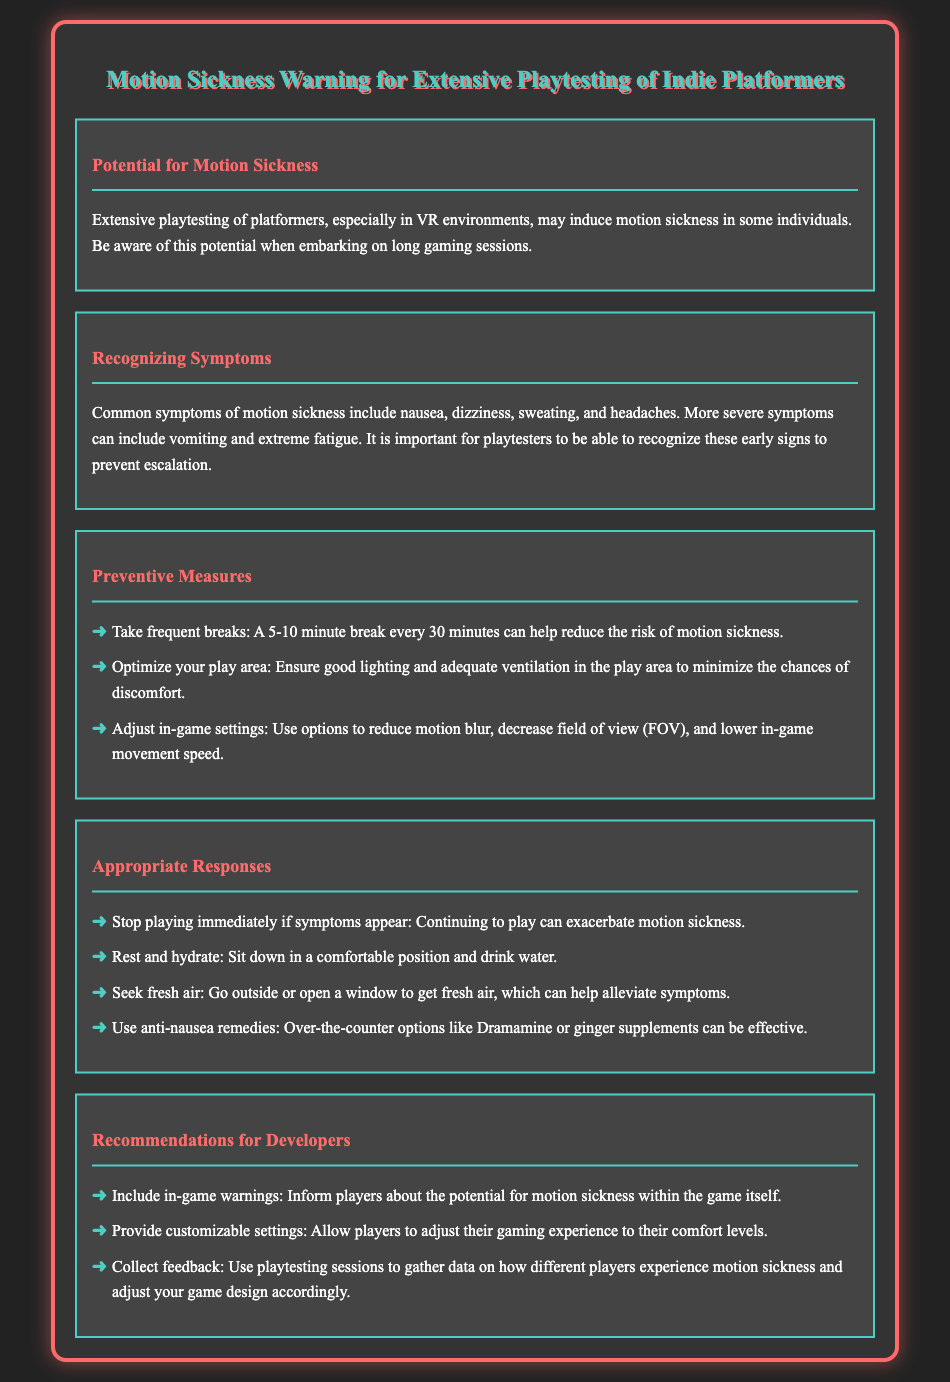what are common symptoms of motion sickness? The document lists nausea, dizziness, sweating, headaches, vomiting, and extreme fatigue as common symptoms.
Answer: nausea, dizziness, sweating, headaches, vomiting, extreme fatigue how long should breaks be during playtesting? The document states that a 5-10 minute break every 30 minutes can help reduce the risk of motion sickness.
Answer: 5-10 minutes what should you do if symptoms appear? The document advises stopping playing immediately if symptoms appear.
Answer: Stop playing immediately what is a preventive measure regarding the play area? The document suggests ensuring good lighting and adequate ventilation in the play area as a preventive measure.
Answer: Good lighting and ventilation which remedy is mentioned for nausea? The document mentions over-the-counter options like Dramamine or ginger supplements as remedies for nausea.
Answer: Dramamine, ginger supplements what potential issue does extensive playtesting in VR environments pose? The document highlights that extensive playtesting may induce motion sickness in some individuals.
Answer: Motion sickness how can developers help players regarding motion sickness? The document recommends including in-game warnings to inform players about the potential for motion sickness.
Answer: In-game warnings what is one adjustment suggested for in-game settings? The document suggests reducing motion blur as one adjustment for in-game settings.
Answer: Reduce motion blur 